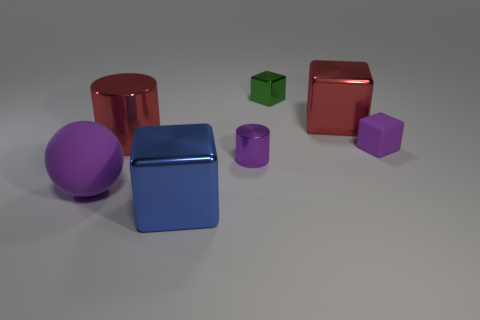There is a cylinder that is the same size as the ball; what color is it?
Provide a short and direct response. Red. Is the blue block the same size as the red shiny block?
Your response must be concise. Yes. There is a blue shiny block; how many purple rubber objects are to the left of it?
Keep it short and to the point. 1. What number of objects are either metal blocks that are in front of the purple rubber sphere or big rubber objects?
Make the answer very short. 2. Are there more red cylinders in front of the large metal cylinder than tiny matte cubes that are in front of the big purple rubber ball?
Your answer should be very brief. No. There is a shiny cylinder that is the same color as the rubber block; what is its size?
Give a very brief answer. Small. There is a purple metallic cylinder; is it the same size as the rubber thing that is in front of the purple rubber cube?
Give a very brief answer. No. What number of cylinders are either small metal objects or cyan rubber objects?
Keep it short and to the point. 1. There is a purple cylinder that is the same material as the blue thing; what is its size?
Your response must be concise. Small. Do the shiny cylinder behind the tiny matte block and the purple rubber thing on the left side of the small purple block have the same size?
Provide a short and direct response. Yes. 